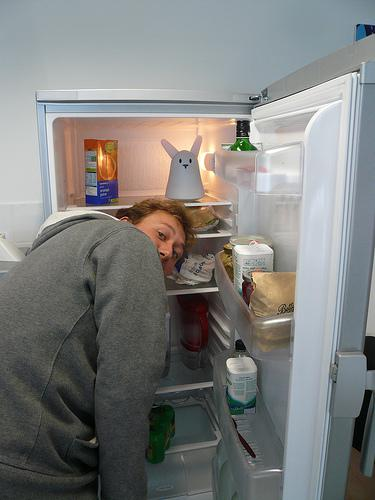Question: what type of scene is this?
Choices:
A. Outdoor.
B. Indoor.
C. Beach scene.
D. Party scene.
Answer with the letter. Answer: B Question: what gender is the person?
Choices:
A. Male.
B. Non-gendered.
C. Hermaphrodite.
D. Female.
Answer with the letter. Answer: D Question: where was the photo taken?
Choices:
A. The deck.
B. The den.
C. Kitchen.
D. The porch.
Answer with the letter. Answer: C 